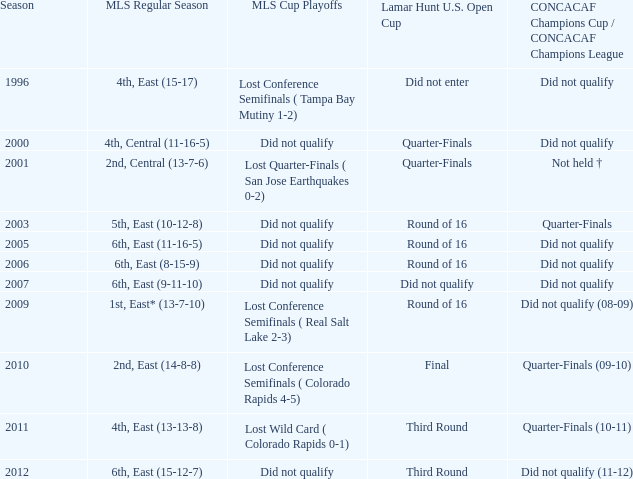What was the lamar hunt u.s. open cup when concacaf champions cup / concacaf champions league was did not qualify and mls regular season was 4th, central (11-16-5)? Quarter-Finals. 